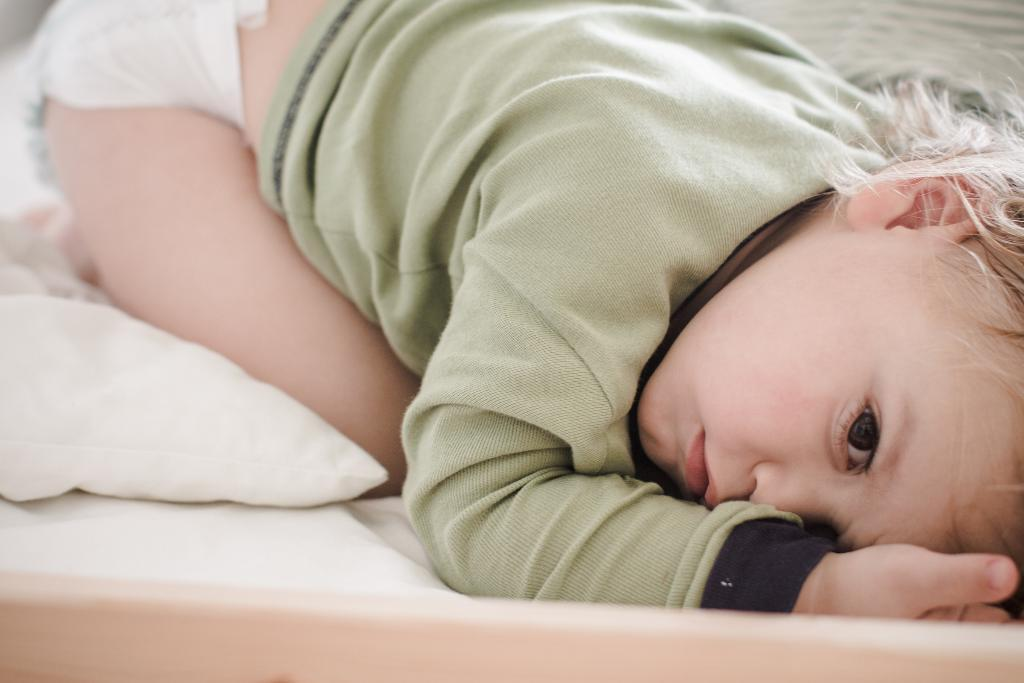What is the main subject of the image? The main subject of the image is a kid. Where is the kid located in the image? The kid is on a bed. What type of smell can be detected coming from the popcorn in the image? There is no popcorn present in the image, so it is not possible to determine what it might smell like. 